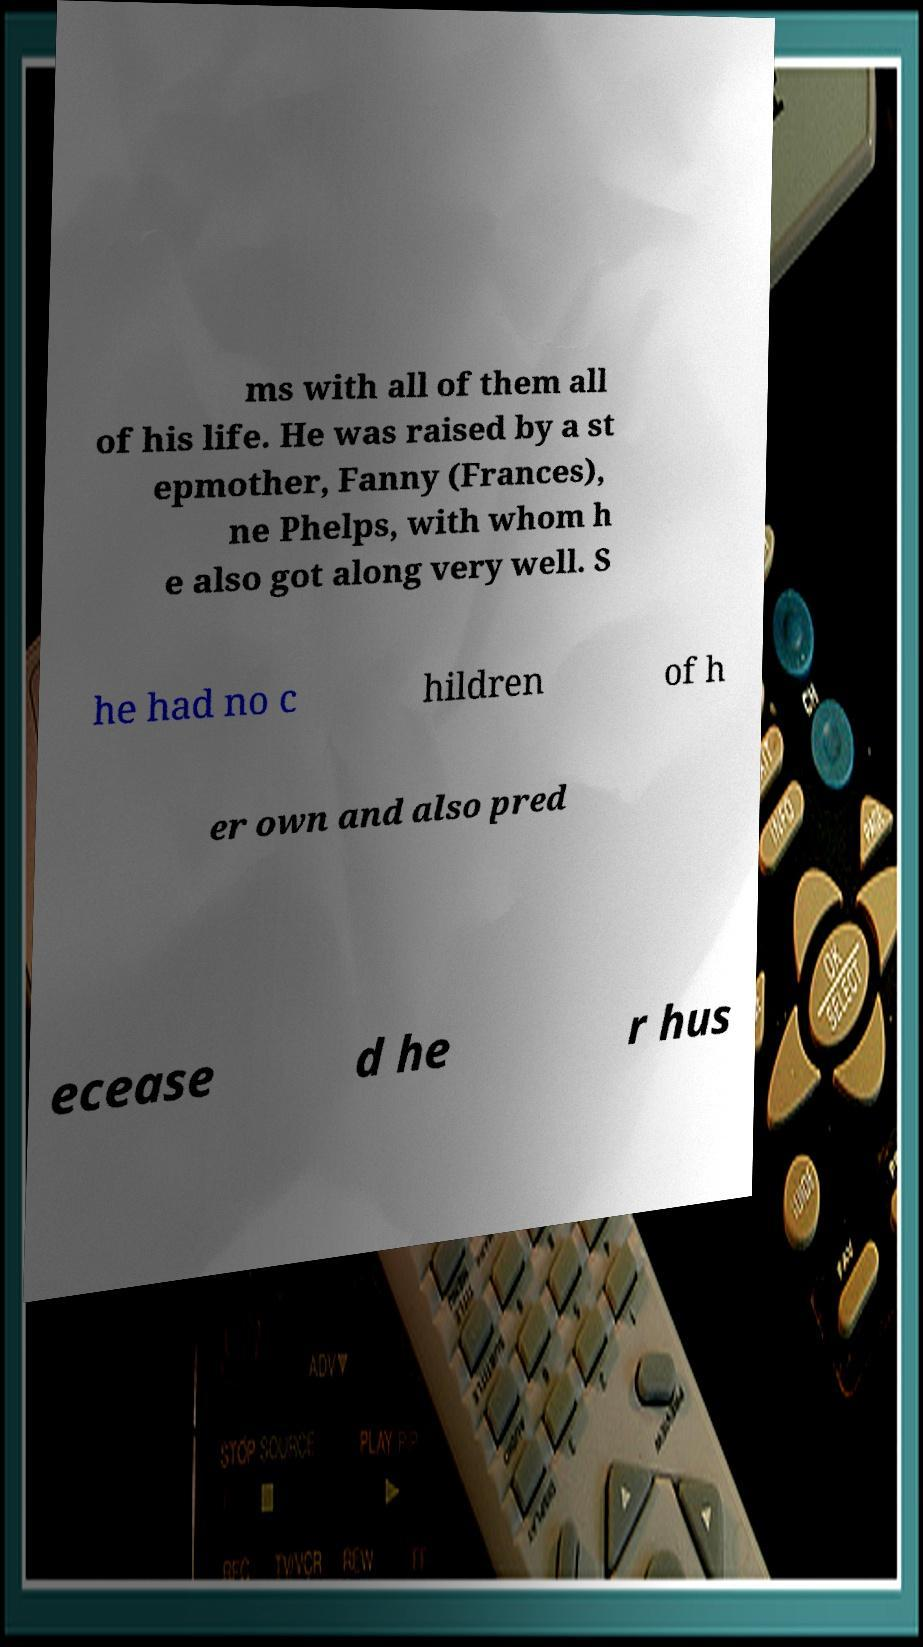Can you accurately transcribe the text from the provided image for me? ms with all of them all of his life. He was raised by a st epmother, Fanny (Frances), ne Phelps, with whom h e also got along very well. S he had no c hildren of h er own and also pred ecease d he r hus 